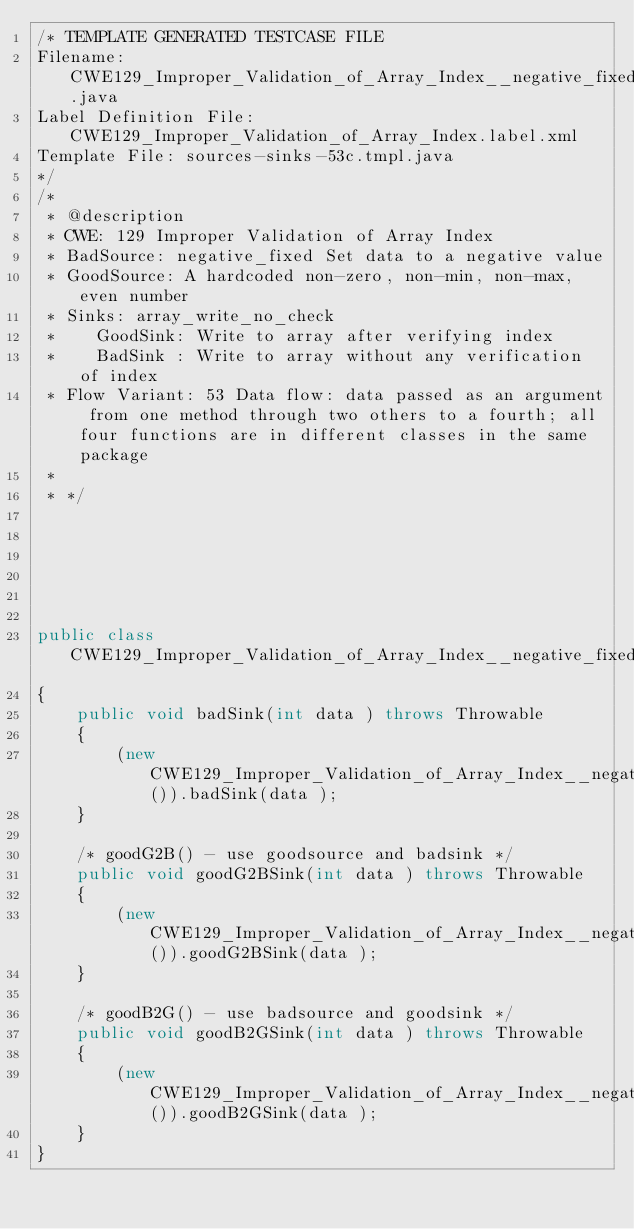<code> <loc_0><loc_0><loc_500><loc_500><_Java_>/* TEMPLATE GENERATED TESTCASE FILE
Filename: CWE129_Improper_Validation_of_Array_Index__negative_fixed_array_write_no_check_53c.java
Label Definition File: CWE129_Improper_Validation_of_Array_Index.label.xml
Template File: sources-sinks-53c.tmpl.java
*/
/*
 * @description
 * CWE: 129 Improper Validation of Array Index
 * BadSource: negative_fixed Set data to a negative value
 * GoodSource: A hardcoded non-zero, non-min, non-max, even number
 * Sinks: array_write_no_check
 *    GoodSink: Write to array after verifying index
 *    BadSink : Write to array without any verification of index
 * Flow Variant: 53 Data flow: data passed as an argument from one method through two others to a fourth; all four functions are in different classes in the same package
 *
 * */






public class CWE129_Improper_Validation_of_Array_Index__negative_fixed_array_write_no_check_53c
{
    public void badSink(int data ) throws Throwable
    {
        (new CWE129_Improper_Validation_of_Array_Index__negative_fixed_array_write_no_check_53d()).badSink(data );
    }

    /* goodG2B() - use goodsource and badsink */
    public void goodG2BSink(int data ) throws Throwable
    {
        (new CWE129_Improper_Validation_of_Array_Index__negative_fixed_array_write_no_check_53d()).goodG2BSink(data );
    }

    /* goodB2G() - use badsource and goodsink */
    public void goodB2GSink(int data ) throws Throwable
    {
        (new CWE129_Improper_Validation_of_Array_Index__negative_fixed_array_write_no_check_53d()).goodB2GSink(data );
    }
}
</code> 